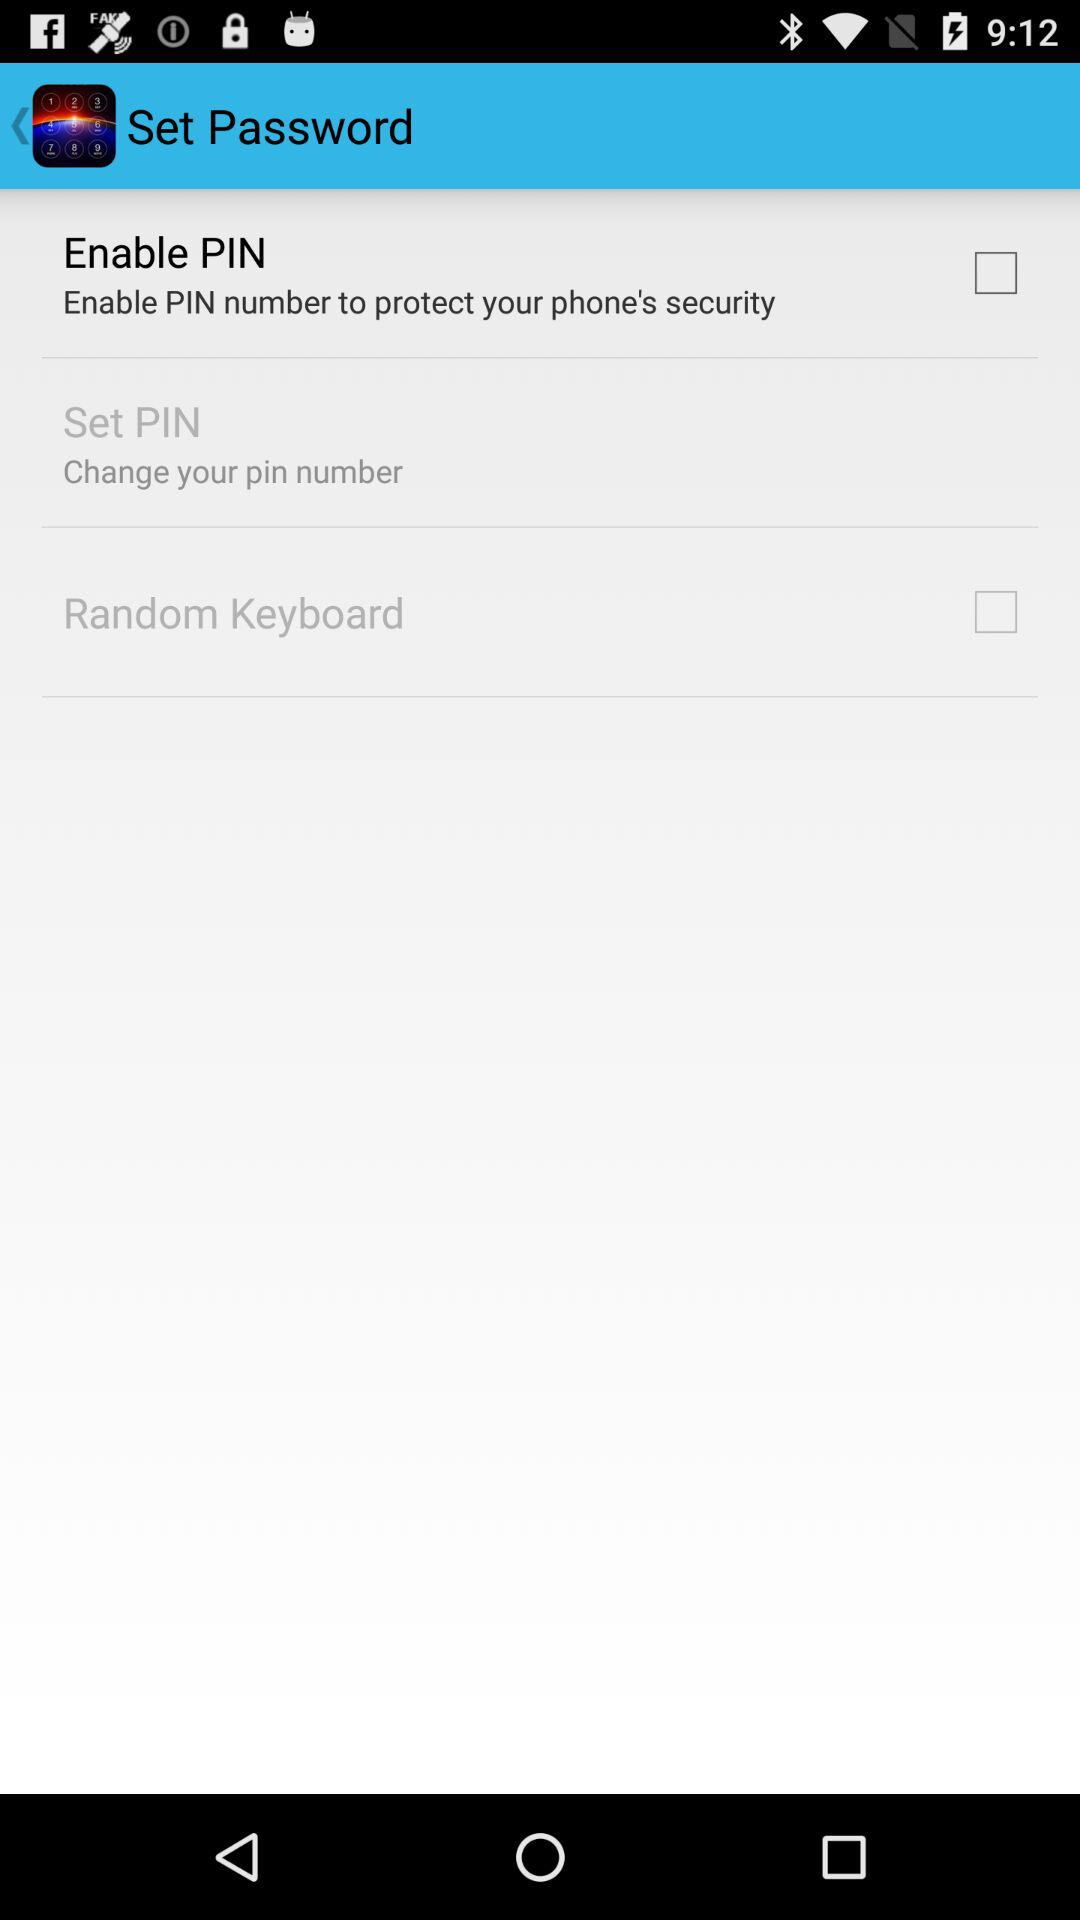What is the status of "Enable PIN"? The status is "off". 